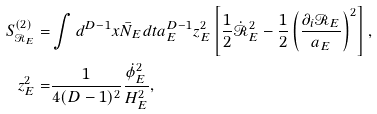Convert formula to latex. <formula><loc_0><loc_0><loc_500><loc_500>S ^ { ( 2 ) } _ { \mathcal { R } _ { E } } = & \int d ^ { D - 1 } x \bar { N } _ { E } d t a _ { E } ^ { D - 1 } z _ { E } ^ { 2 } \left [ \frac { 1 } { 2 } \dot { \mathcal { R } } _ { E } ^ { 2 } - \frac { 1 } { 2 } \left ( \frac { \partial _ { i } \mathcal { R } _ { E } } { a _ { E } } \right ) ^ { 2 } \right ] , \\ z _ { E } ^ { 2 } = & \frac { 1 } { 4 ( D - 1 ) ^ { 2 } } \frac { \dot { \phi } _ { E } ^ { 2 } } { H _ { E } ^ { 2 } } ,</formula> 